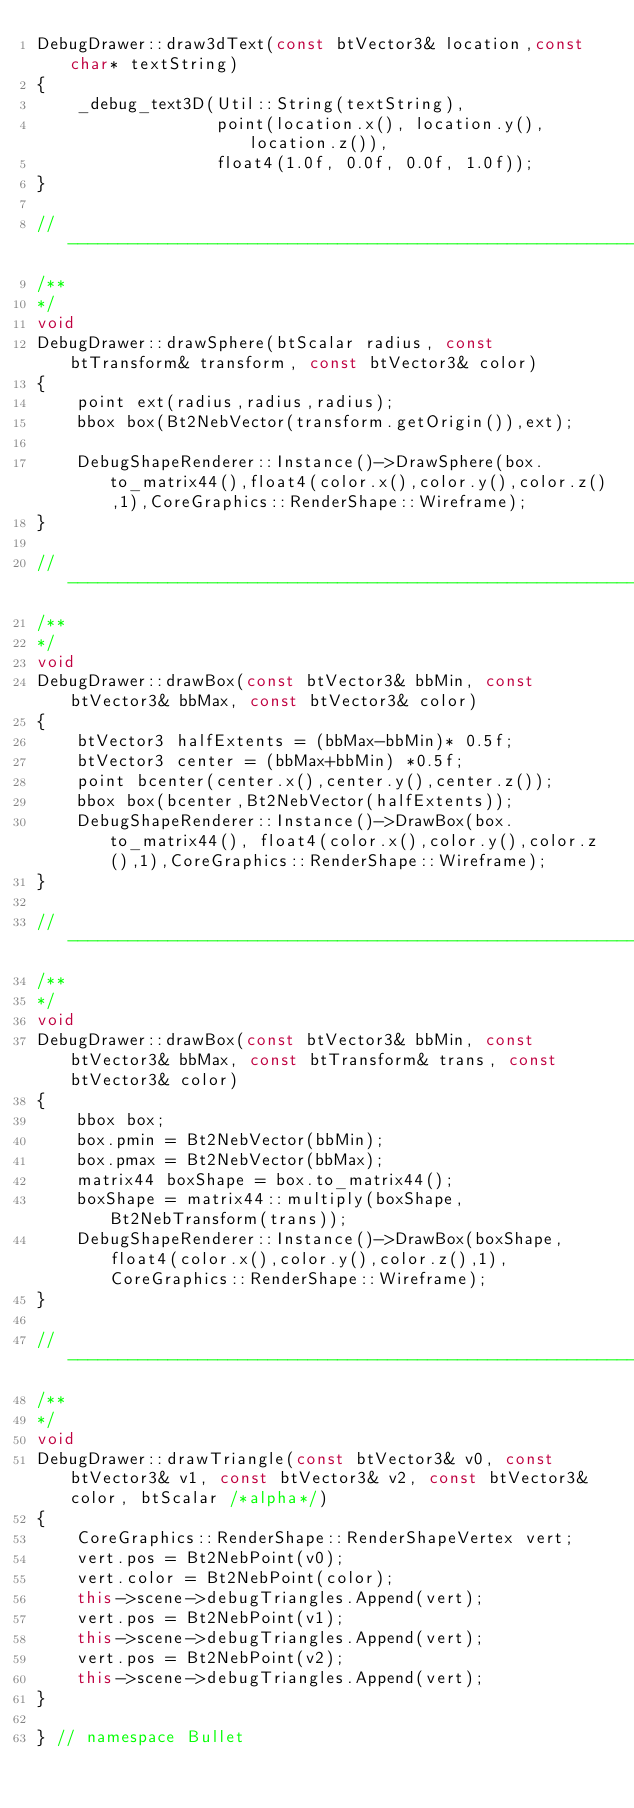<code> <loc_0><loc_0><loc_500><loc_500><_C++_>DebugDrawer::draw3dText(const btVector3& location,const char* textString)
{
    _debug_text3D(Util::String(textString), 
                  point(location.x(), location.y(), location.z()), 
                  float4(1.0f, 0.0f, 0.0f, 1.0f));     
}

//------------------------------------------------------------------------------
/**
*/
void
DebugDrawer::drawSphere(btScalar radius, const btTransform& transform, const btVector3& color)
{
	point ext(radius,radius,radius);
	bbox box(Bt2NebVector(transform.getOrigin()),ext);	

	DebugShapeRenderer::Instance()->DrawSphere(box.to_matrix44(),float4(color.x(),color.y(),color.z(),1),CoreGraphics::RenderShape::Wireframe);
}

//------------------------------------------------------------------------------
/**
*/
void	
DebugDrawer::drawBox(const btVector3& bbMin, const btVector3& bbMax, const btVector3& color)
{
	btVector3 halfExtents = (bbMax-bbMin)* 0.5f;
	btVector3 center = (bbMax+bbMin) *0.5f;
	point bcenter(center.x(),center.y(),center.z());
	bbox box(bcenter,Bt2NebVector(halfExtents));
	DebugShapeRenderer::Instance()->DrawBox(box.to_matrix44(), float4(color.x(),color.y(),color.z(),1),CoreGraphics::RenderShape::Wireframe);
}

//------------------------------------------------------------------------------
/**
*/
void	
DebugDrawer::drawBox(const btVector3& bbMin, const btVector3& bbMax, const btTransform& trans, const btVector3& color)
{	
	bbox box;
	box.pmin = Bt2NebVector(bbMin);
	box.pmax = Bt2NebVector(bbMax);
	matrix44 boxShape = box.to_matrix44();
	boxShape = matrix44::multiply(boxShape, Bt2NebTransform(trans));
	DebugShapeRenderer::Instance()->DrawBox(boxShape, float4(color.x(),color.y(),color.z(),1),CoreGraphics::RenderShape::Wireframe);
}

//------------------------------------------------------------------------------
/**
*/
void
DebugDrawer::drawTriangle(const btVector3& v0, const btVector3& v1, const btVector3& v2, const btVector3& color, btScalar /*alpha*/)
{
    CoreGraphics::RenderShape::RenderShapeVertex vert;
    vert.pos = Bt2NebPoint(v0);
    vert.color = Bt2NebPoint(color);
    this->scene->debugTriangles.Append(vert);
    vert.pos = Bt2NebPoint(v1);    
    this->scene->debugTriangles.Append(vert);
    vert.pos = Bt2NebPoint(v2);
    this->scene->debugTriangles.Append(vert);
}

} // namespace Bullet</code> 